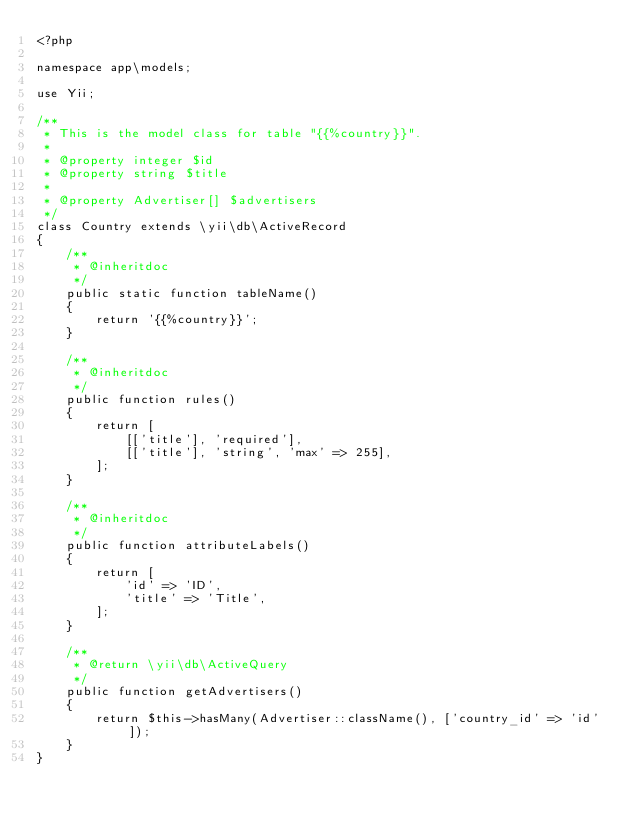<code> <loc_0><loc_0><loc_500><loc_500><_PHP_><?php

namespace app\models;

use Yii;

/**
 * This is the model class for table "{{%country}}".
 *
 * @property integer $id
 * @property string $title
 *
 * @property Advertiser[] $advertisers
 */
class Country extends \yii\db\ActiveRecord
{
    /**
     * @inheritdoc
     */
    public static function tableName()
    {
        return '{{%country}}';
    }

    /**
     * @inheritdoc
     */
    public function rules()
    {
        return [
            [['title'], 'required'],
            [['title'], 'string', 'max' => 255],
        ];
    }

    /**
     * @inheritdoc
     */
    public function attributeLabels()
    {
        return [
            'id' => 'ID',
            'title' => 'Title',
        ];
    }

    /**
     * @return \yii\db\ActiveQuery
     */
    public function getAdvertisers()
    {
        return $this->hasMany(Advertiser::className(), ['country_id' => 'id']);
    }
}
</code> 